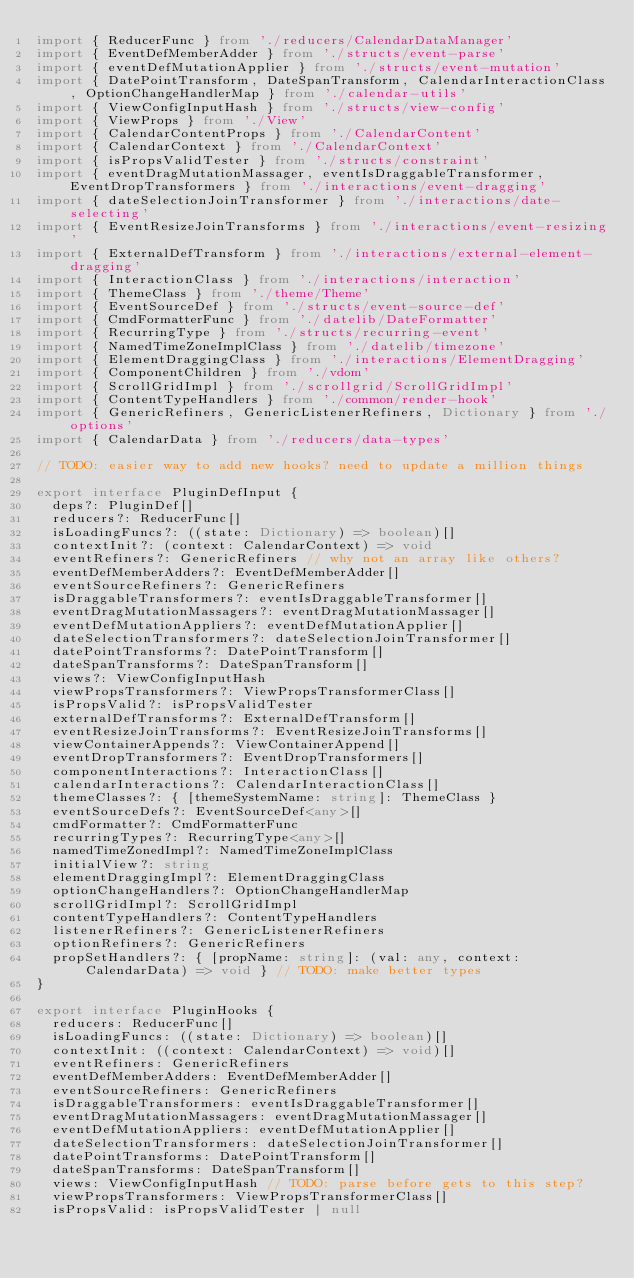Convert code to text. <code><loc_0><loc_0><loc_500><loc_500><_TypeScript_>import { ReducerFunc } from './reducers/CalendarDataManager'
import { EventDefMemberAdder } from './structs/event-parse'
import { eventDefMutationApplier } from './structs/event-mutation'
import { DatePointTransform, DateSpanTransform, CalendarInteractionClass, OptionChangeHandlerMap } from './calendar-utils'
import { ViewConfigInputHash } from './structs/view-config'
import { ViewProps } from './View'
import { CalendarContentProps } from './CalendarContent'
import { CalendarContext } from './CalendarContext'
import { isPropsValidTester } from './structs/constraint'
import { eventDragMutationMassager, eventIsDraggableTransformer, EventDropTransformers } from './interactions/event-dragging'
import { dateSelectionJoinTransformer } from './interactions/date-selecting'
import { EventResizeJoinTransforms } from './interactions/event-resizing'
import { ExternalDefTransform } from './interactions/external-element-dragging'
import { InteractionClass } from './interactions/interaction'
import { ThemeClass } from './theme/Theme'
import { EventSourceDef } from './structs/event-source-def'
import { CmdFormatterFunc } from './datelib/DateFormatter'
import { RecurringType } from './structs/recurring-event'
import { NamedTimeZoneImplClass } from './datelib/timezone'
import { ElementDraggingClass } from './interactions/ElementDragging'
import { ComponentChildren } from './vdom'
import { ScrollGridImpl } from './scrollgrid/ScrollGridImpl'
import { ContentTypeHandlers } from './common/render-hook'
import { GenericRefiners, GenericListenerRefiners, Dictionary } from './options'
import { CalendarData } from './reducers/data-types'

// TODO: easier way to add new hooks? need to update a million things

export interface PluginDefInput {
  deps?: PluginDef[]
  reducers?: ReducerFunc[]
  isLoadingFuncs?: ((state: Dictionary) => boolean)[]
  contextInit?: (context: CalendarContext) => void
  eventRefiners?: GenericRefiners // why not an array like others?
  eventDefMemberAdders?: EventDefMemberAdder[]
  eventSourceRefiners?: GenericRefiners
  isDraggableTransformers?: eventIsDraggableTransformer[]
  eventDragMutationMassagers?: eventDragMutationMassager[]
  eventDefMutationAppliers?: eventDefMutationApplier[]
  dateSelectionTransformers?: dateSelectionJoinTransformer[]
  datePointTransforms?: DatePointTransform[]
  dateSpanTransforms?: DateSpanTransform[]
  views?: ViewConfigInputHash
  viewPropsTransformers?: ViewPropsTransformerClass[]
  isPropsValid?: isPropsValidTester
  externalDefTransforms?: ExternalDefTransform[]
  eventResizeJoinTransforms?: EventResizeJoinTransforms[]
  viewContainerAppends?: ViewContainerAppend[]
  eventDropTransformers?: EventDropTransformers[]
  componentInteractions?: InteractionClass[]
  calendarInteractions?: CalendarInteractionClass[]
  themeClasses?: { [themeSystemName: string]: ThemeClass }
  eventSourceDefs?: EventSourceDef<any>[]
  cmdFormatter?: CmdFormatterFunc
  recurringTypes?: RecurringType<any>[]
  namedTimeZonedImpl?: NamedTimeZoneImplClass
  initialView?: string
  elementDraggingImpl?: ElementDraggingClass
  optionChangeHandlers?: OptionChangeHandlerMap
  scrollGridImpl?: ScrollGridImpl
  contentTypeHandlers?: ContentTypeHandlers
  listenerRefiners?: GenericListenerRefiners
  optionRefiners?: GenericRefiners
  propSetHandlers?: { [propName: string]: (val: any, context: CalendarData) => void } // TODO: make better types
}

export interface PluginHooks {
  reducers: ReducerFunc[]
  isLoadingFuncs: ((state: Dictionary) => boolean)[]
  contextInit: ((context: CalendarContext) => void)[]
  eventRefiners: GenericRefiners
  eventDefMemberAdders: EventDefMemberAdder[]
  eventSourceRefiners: GenericRefiners
  isDraggableTransformers: eventIsDraggableTransformer[]
  eventDragMutationMassagers: eventDragMutationMassager[]
  eventDefMutationAppliers: eventDefMutationApplier[]
  dateSelectionTransformers: dateSelectionJoinTransformer[]
  datePointTransforms: DatePointTransform[]
  dateSpanTransforms: DateSpanTransform[]
  views: ViewConfigInputHash // TODO: parse before gets to this step?
  viewPropsTransformers: ViewPropsTransformerClass[]
  isPropsValid: isPropsValidTester | null</code> 